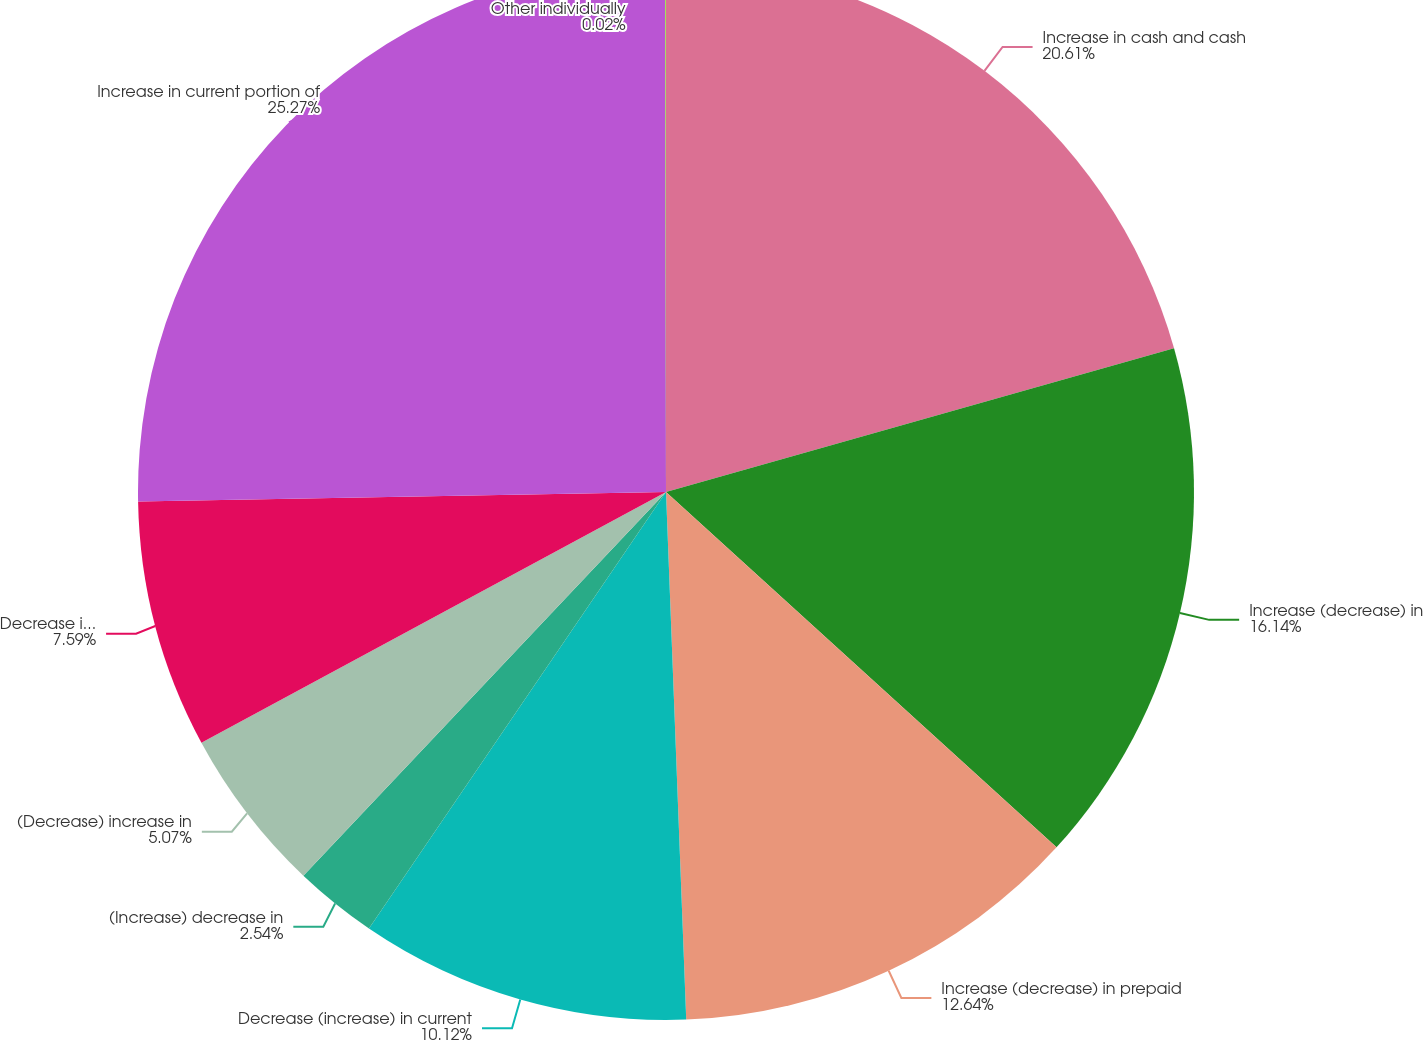Convert chart. <chart><loc_0><loc_0><loc_500><loc_500><pie_chart><fcel>Increase in cash and cash<fcel>Increase (decrease) in<fcel>Increase (decrease) in prepaid<fcel>Decrease (increase) in current<fcel>(Increase) decrease in<fcel>(Decrease) increase in<fcel>Decrease in receivables net<fcel>Increase in current portion of<fcel>Other individually<nl><fcel>20.61%<fcel>16.14%<fcel>12.64%<fcel>10.12%<fcel>2.54%<fcel>5.07%<fcel>7.59%<fcel>25.27%<fcel>0.02%<nl></chart> 